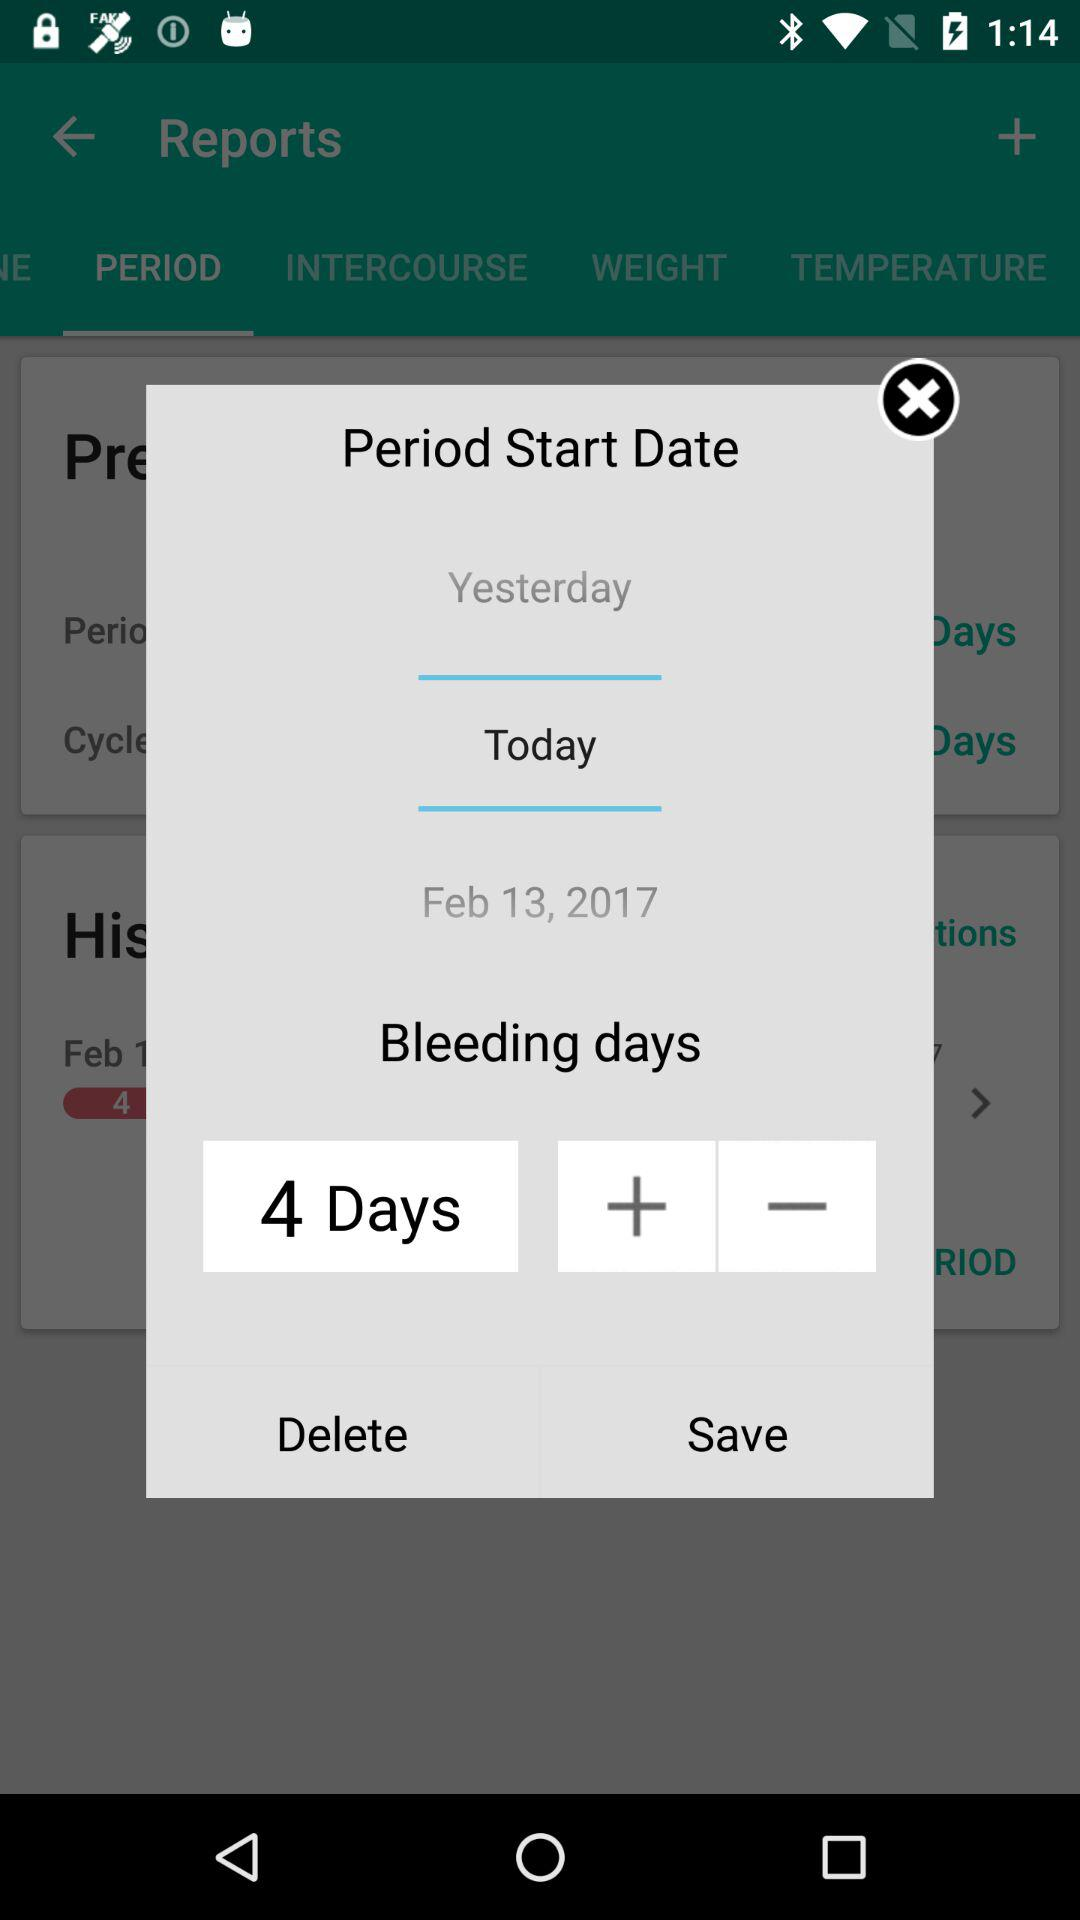What will be tomorrow's date? Tomorrow's date will be February 13, 2017. 